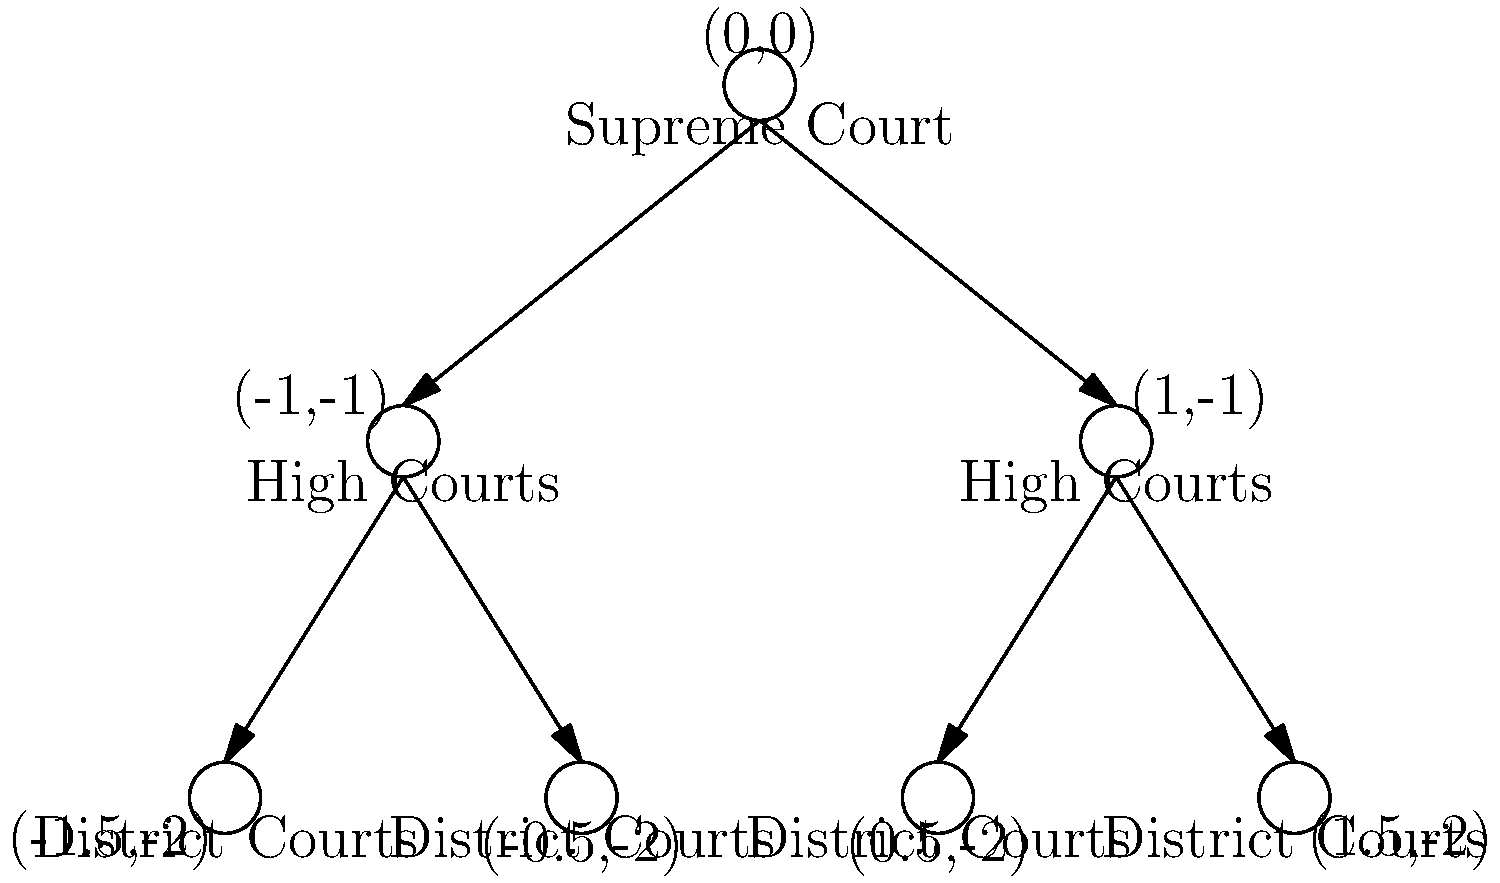In the given tree diagram representing the hierarchy of the Indian judicial system, what are the coordinates of the node representing the Supreme Court? To answer this question, we need to analyze the tree diagram of the Indian judicial system:

1. The diagram shows a hierarchical structure with three levels:
   - Top level: Supreme Court
   - Middle level: High Courts
   - Bottom level: District Courts

2. Each node in the diagram is labeled with its coordinates in the format (x,y).

3. The Supreme Court, being at the top of the hierarchy, is positioned at the highest point in the diagram.

4. Looking at the coordinates labeled for each node, we can see that the Supreme Court is positioned at the point (0,0).

5. This coordinate (0,0) represents the origin of the coordinate system, which is appropriate for the apex court in the judicial hierarchy.

6. The High Courts are positioned at (-1,-1) and (1,-1), showing their subordinate position to the Supreme Court.

7. The District Courts are at the lowest level, with coordinates (-1.5,-2), (-0.5,-2), (0.5,-2), and (1.5,-2), representing their position at the base of the judicial pyramid.

Therefore, the coordinates of the node representing the Supreme Court in this diagram are (0,0).
Answer: (0,0) 